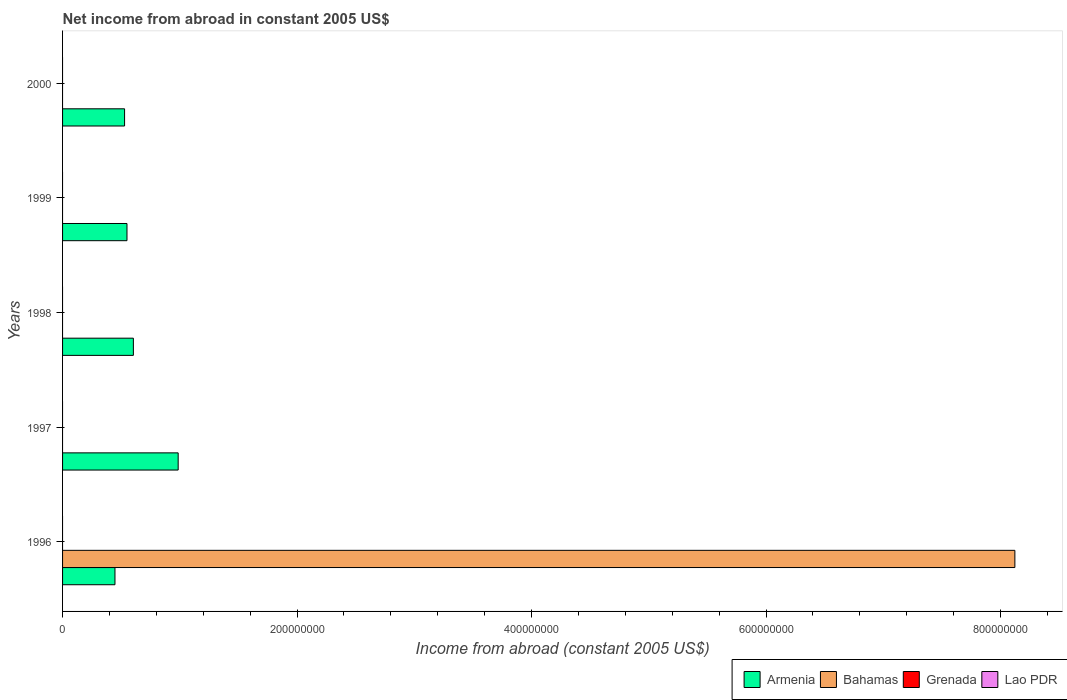How many different coloured bars are there?
Ensure brevity in your answer.  2. Are the number of bars per tick equal to the number of legend labels?
Give a very brief answer. No. What is the net income from abroad in Armenia in 1997?
Your response must be concise. 9.86e+07. Across all years, what is the maximum net income from abroad in Armenia?
Ensure brevity in your answer.  9.86e+07. Across all years, what is the minimum net income from abroad in Lao PDR?
Provide a succinct answer. 0. In which year was the net income from abroad in Bahamas maximum?
Your answer should be very brief. 1996. What is the total net income from abroad in Armenia in the graph?
Ensure brevity in your answer.  3.12e+08. What is the difference between the net income from abroad in Armenia in 1997 and that in 1999?
Provide a short and direct response. 4.37e+07. What is the average net income from abroad in Bahamas per year?
Provide a succinct answer. 1.62e+08. What is the ratio of the net income from abroad in Armenia in 1996 to that in 2000?
Offer a very short reply. 0.84. Is the net income from abroad in Armenia in 1996 less than that in 1998?
Your response must be concise. Yes. What is the difference between the highest and the second highest net income from abroad in Armenia?
Ensure brevity in your answer.  3.82e+07. What is the difference between the highest and the lowest net income from abroad in Bahamas?
Your answer should be very brief. 8.12e+08. In how many years, is the net income from abroad in Lao PDR greater than the average net income from abroad in Lao PDR taken over all years?
Your answer should be compact. 0. Is it the case that in every year, the sum of the net income from abroad in Grenada and net income from abroad in Armenia is greater than the sum of net income from abroad in Bahamas and net income from abroad in Lao PDR?
Provide a succinct answer. Yes. Is it the case that in every year, the sum of the net income from abroad in Grenada and net income from abroad in Armenia is greater than the net income from abroad in Lao PDR?
Offer a terse response. Yes. How many bars are there?
Your answer should be very brief. 6. Are the values on the major ticks of X-axis written in scientific E-notation?
Your response must be concise. No. Does the graph contain any zero values?
Your response must be concise. Yes. Does the graph contain grids?
Make the answer very short. No. Where does the legend appear in the graph?
Give a very brief answer. Bottom right. How many legend labels are there?
Your response must be concise. 4. How are the legend labels stacked?
Make the answer very short. Horizontal. What is the title of the graph?
Your answer should be compact. Net income from abroad in constant 2005 US$. Does "Heavily indebted poor countries" appear as one of the legend labels in the graph?
Ensure brevity in your answer.  No. What is the label or title of the X-axis?
Ensure brevity in your answer.  Income from abroad (constant 2005 US$). What is the label or title of the Y-axis?
Keep it short and to the point. Years. What is the Income from abroad (constant 2005 US$) in Armenia in 1996?
Give a very brief answer. 4.47e+07. What is the Income from abroad (constant 2005 US$) of Bahamas in 1996?
Your response must be concise. 8.12e+08. What is the Income from abroad (constant 2005 US$) of Grenada in 1996?
Your response must be concise. 0. What is the Income from abroad (constant 2005 US$) in Armenia in 1997?
Give a very brief answer. 9.86e+07. What is the Income from abroad (constant 2005 US$) in Bahamas in 1997?
Keep it short and to the point. 0. What is the Income from abroad (constant 2005 US$) of Lao PDR in 1997?
Your response must be concise. 0. What is the Income from abroad (constant 2005 US$) of Armenia in 1998?
Ensure brevity in your answer.  6.04e+07. What is the Income from abroad (constant 2005 US$) of Grenada in 1998?
Your answer should be very brief. 0. What is the Income from abroad (constant 2005 US$) in Armenia in 1999?
Your response must be concise. 5.49e+07. What is the Income from abroad (constant 2005 US$) of Bahamas in 1999?
Offer a terse response. 0. What is the Income from abroad (constant 2005 US$) in Grenada in 1999?
Ensure brevity in your answer.  0. What is the Income from abroad (constant 2005 US$) in Lao PDR in 1999?
Make the answer very short. 0. What is the Income from abroad (constant 2005 US$) of Armenia in 2000?
Offer a very short reply. 5.29e+07. What is the Income from abroad (constant 2005 US$) in Lao PDR in 2000?
Your answer should be very brief. 0. Across all years, what is the maximum Income from abroad (constant 2005 US$) of Armenia?
Ensure brevity in your answer.  9.86e+07. Across all years, what is the maximum Income from abroad (constant 2005 US$) in Bahamas?
Make the answer very short. 8.12e+08. Across all years, what is the minimum Income from abroad (constant 2005 US$) of Armenia?
Make the answer very short. 4.47e+07. What is the total Income from abroad (constant 2005 US$) in Armenia in the graph?
Offer a very short reply. 3.12e+08. What is the total Income from abroad (constant 2005 US$) of Bahamas in the graph?
Your answer should be compact. 8.12e+08. What is the total Income from abroad (constant 2005 US$) in Grenada in the graph?
Keep it short and to the point. 0. What is the total Income from abroad (constant 2005 US$) in Lao PDR in the graph?
Keep it short and to the point. 0. What is the difference between the Income from abroad (constant 2005 US$) in Armenia in 1996 and that in 1997?
Provide a succinct answer. -5.39e+07. What is the difference between the Income from abroad (constant 2005 US$) in Armenia in 1996 and that in 1998?
Your response must be concise. -1.57e+07. What is the difference between the Income from abroad (constant 2005 US$) in Armenia in 1996 and that in 1999?
Make the answer very short. -1.02e+07. What is the difference between the Income from abroad (constant 2005 US$) of Armenia in 1996 and that in 2000?
Give a very brief answer. -8.20e+06. What is the difference between the Income from abroad (constant 2005 US$) of Armenia in 1997 and that in 1998?
Ensure brevity in your answer.  3.82e+07. What is the difference between the Income from abroad (constant 2005 US$) in Armenia in 1997 and that in 1999?
Offer a very short reply. 4.37e+07. What is the difference between the Income from abroad (constant 2005 US$) in Armenia in 1997 and that in 2000?
Keep it short and to the point. 4.57e+07. What is the difference between the Income from abroad (constant 2005 US$) in Armenia in 1998 and that in 1999?
Provide a succinct answer. 5.46e+06. What is the difference between the Income from abroad (constant 2005 US$) of Armenia in 1998 and that in 2000?
Make the answer very short. 7.50e+06. What is the difference between the Income from abroad (constant 2005 US$) of Armenia in 1999 and that in 2000?
Make the answer very short. 2.04e+06. What is the average Income from abroad (constant 2005 US$) of Armenia per year?
Provide a succinct answer. 6.23e+07. What is the average Income from abroad (constant 2005 US$) of Bahamas per year?
Your answer should be very brief. 1.62e+08. What is the average Income from abroad (constant 2005 US$) in Grenada per year?
Ensure brevity in your answer.  0. In the year 1996, what is the difference between the Income from abroad (constant 2005 US$) of Armenia and Income from abroad (constant 2005 US$) of Bahamas?
Provide a short and direct response. -7.68e+08. What is the ratio of the Income from abroad (constant 2005 US$) in Armenia in 1996 to that in 1997?
Make the answer very short. 0.45. What is the ratio of the Income from abroad (constant 2005 US$) of Armenia in 1996 to that in 1998?
Your response must be concise. 0.74. What is the ratio of the Income from abroad (constant 2005 US$) of Armenia in 1996 to that in 1999?
Give a very brief answer. 0.81. What is the ratio of the Income from abroad (constant 2005 US$) in Armenia in 1996 to that in 2000?
Provide a succinct answer. 0.84. What is the ratio of the Income from abroad (constant 2005 US$) of Armenia in 1997 to that in 1998?
Provide a succinct answer. 1.63. What is the ratio of the Income from abroad (constant 2005 US$) of Armenia in 1997 to that in 1999?
Your answer should be very brief. 1.79. What is the ratio of the Income from abroad (constant 2005 US$) in Armenia in 1997 to that in 2000?
Keep it short and to the point. 1.86. What is the ratio of the Income from abroad (constant 2005 US$) of Armenia in 1998 to that in 1999?
Offer a very short reply. 1.1. What is the ratio of the Income from abroad (constant 2005 US$) of Armenia in 1998 to that in 2000?
Provide a short and direct response. 1.14. What is the ratio of the Income from abroad (constant 2005 US$) of Armenia in 1999 to that in 2000?
Your response must be concise. 1.04. What is the difference between the highest and the second highest Income from abroad (constant 2005 US$) of Armenia?
Provide a succinct answer. 3.82e+07. What is the difference between the highest and the lowest Income from abroad (constant 2005 US$) in Armenia?
Make the answer very short. 5.39e+07. What is the difference between the highest and the lowest Income from abroad (constant 2005 US$) of Bahamas?
Your response must be concise. 8.12e+08. 